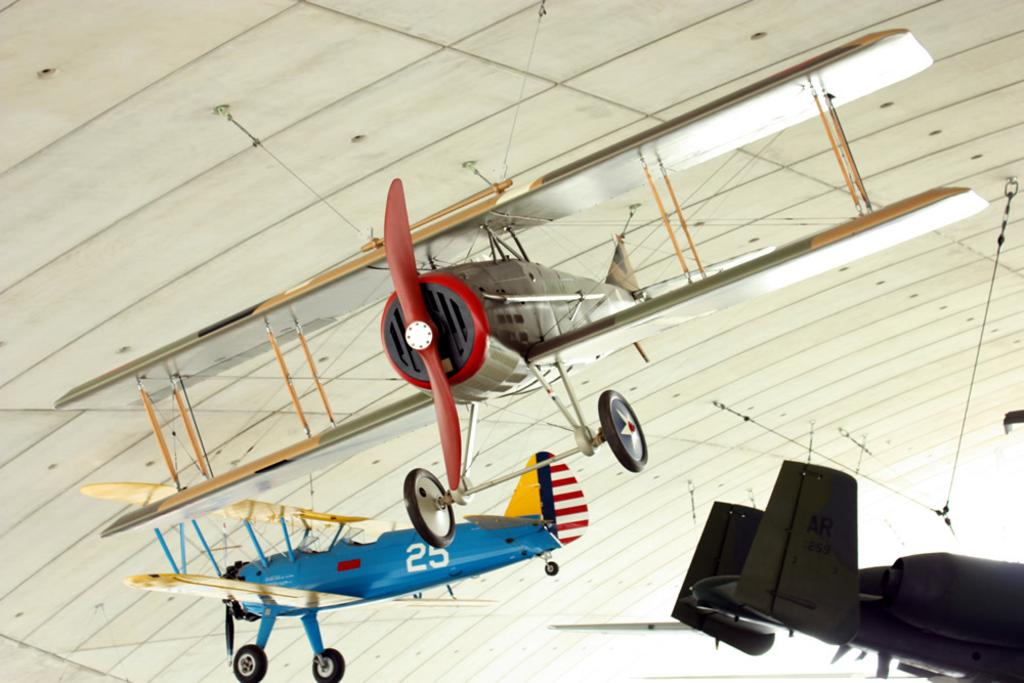Where was the image taken? The image is taken indoors. What can be seen hanging from the roof in the image? There are aircrafts hanging from the roof in the image. What colors are the aircrafts? The aircrafts are of different colors. What part of the room is visible at the top of the image? The roof is visible at the top of the image. What type of animals can be seen at the zoo in the image? There is no zoo or animals present in the image; it features aircrafts hanging from the roof indoors. 